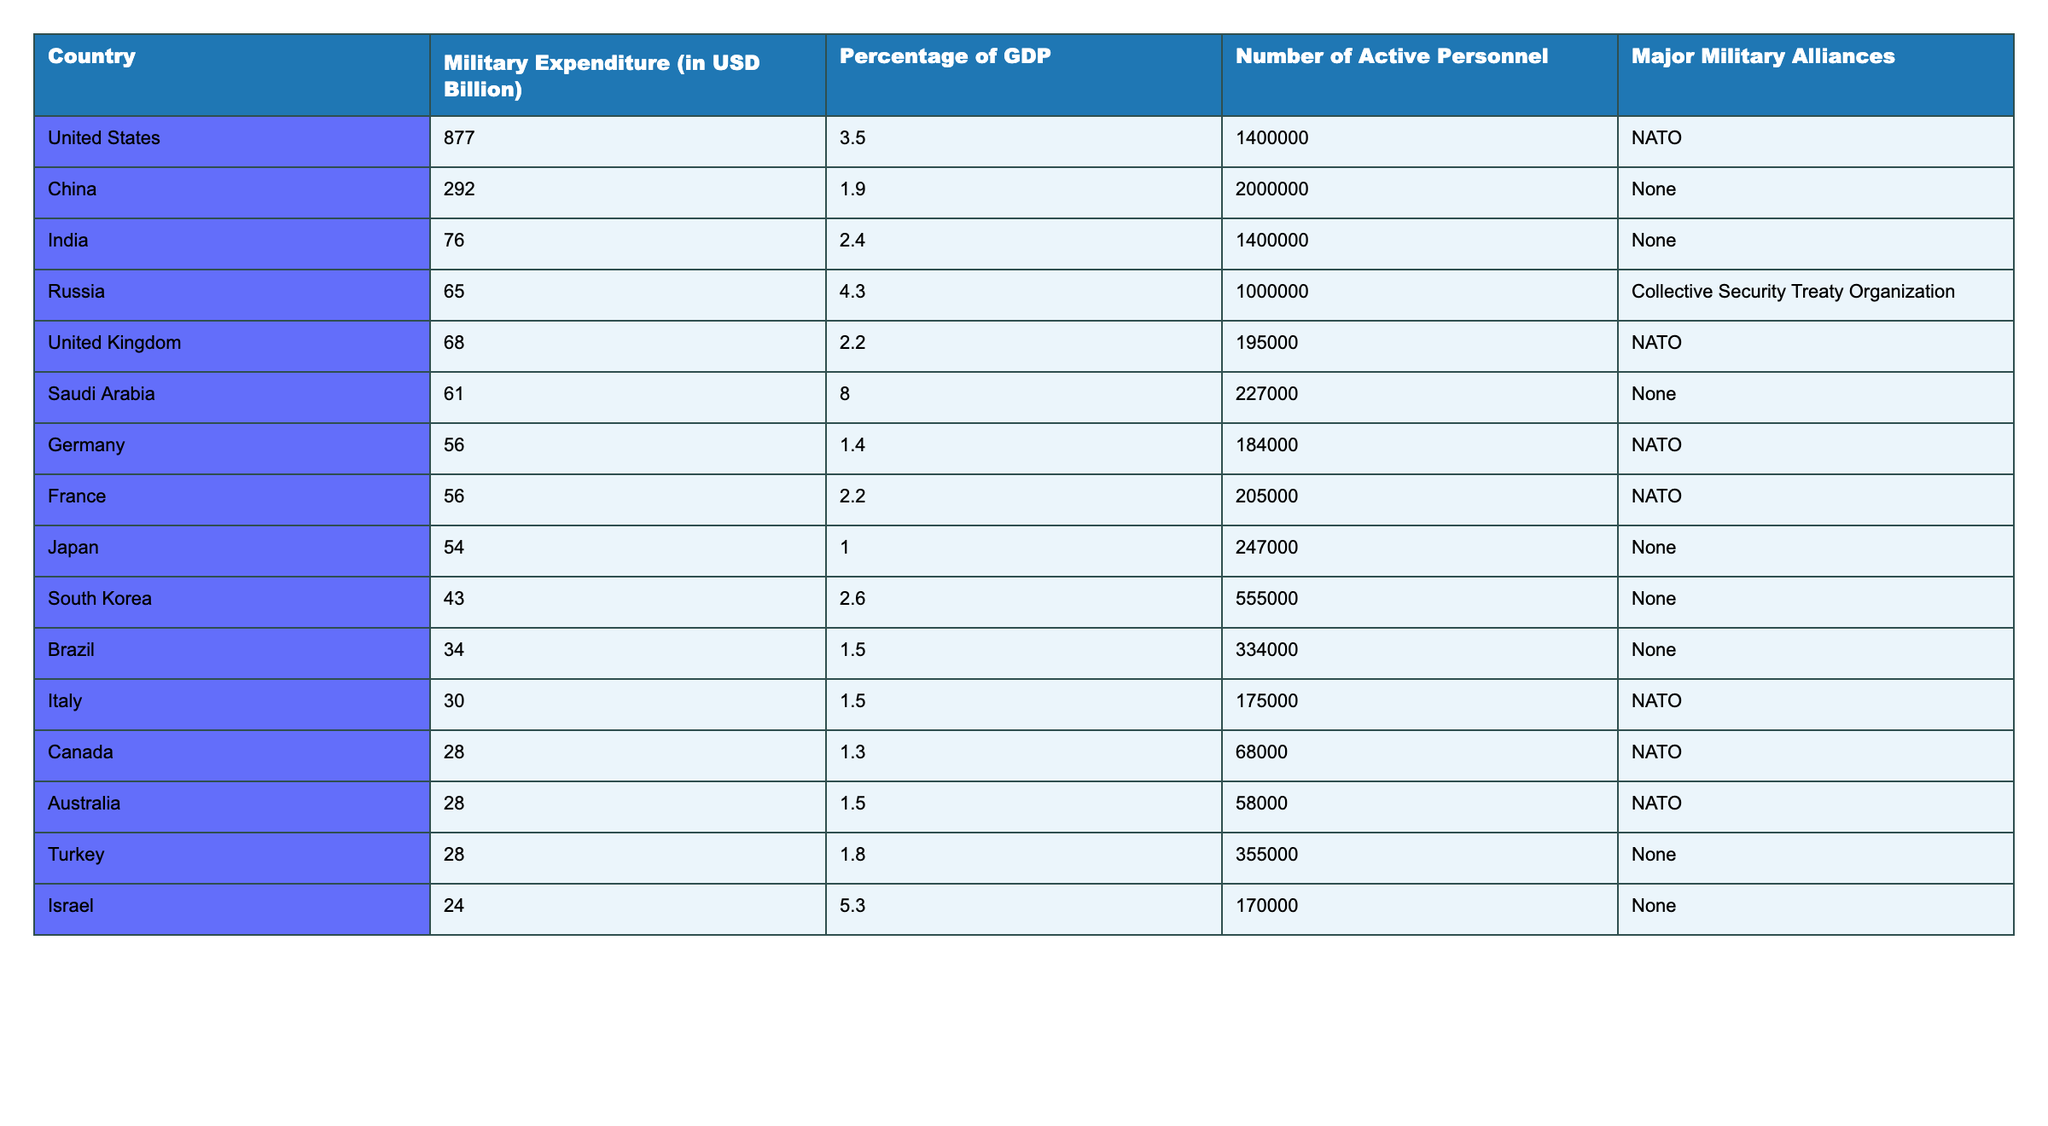What is the military expenditure of the United States in 2022? The table shows that the military expenditure of the United States is listed as 877.0 billion USD.
Answer: 877.0 billion USD How much is India's military expenditure compared to that of Russia? India's military expenditure is 76.0 billion USD, while Russia's is 65.0 billion USD. To find how much greater India's expenditure is, subtract: 76.0 - 65.0 = 11.0 billion USD.
Answer: 11.0 billion USD What percentage of GDP does Saudi Arabia allocate for military expenditure? The table indicates that Saudi Arabia allocates 8.0% of its GDP for military expenditure.
Answer: 8.0% Which country has the highest number of active personnel? China has the highest number of active personnel with 2,000,000, as listed in the table.
Answer: China Is the military expenditure of France greater than that of Germany? The table shows France's military expenditure is 56.0 billion USD, and Germany's is also 56.0 billion USD; therefore, France's expenditure is not greater than Germany's.
Answer: No What is the total military expenditure of all NATO countries listed? The expenditures for NATO countries (United States, United Kingdom, Germany, France, Italy, Canada, Australia) are 877.0 + 68.0 + 56.0 + 56.0 + 30.0 + 28.0 + 28.0 = 1,123.0 billion USD.
Answer: 1,123.0 billion USD What is the median military expenditure of the countries listed in the table? To find the median, first list all expenditures: 877.0, 292.0, 76.0, 65.0, 68.0, 61.0, 56.0, 56.0, 54.0, 43.0, 34.0, 30.0, 28.0, 28.0, 28.0, 24.0. There are 16 data points, so the median is the average of the 8th and 9th values in sorted order (56.0 and 54.0): (56.0 + 54.0) / 2 = 55.0 billion USD.
Answer: 55.0 billion USD Which country spends less on military than the percentage of GDP allocated by Saudi Arabia? Saudi Arabia allocates 8.0% of its GDP for military spending. Looking at the table, only Japan (1.0%) and Germany (1.4%) have lower percentages of GDP; therefore, they both spend less.
Answer: Japan and Germany How much more does the United States spend on military compared to the combined expenditure of Brazil and Turkey? Brazil's expenditure is 34.0 billion USD, and Turkey's is 28.0 billion USD. Their combined expenditure is 34.0 + 28.0 = 62.0 billion USD. The United States spends 877.0 billion USD, so the difference is 877.0 - 62.0 = 815.0 billion USD.
Answer: 815.0 billion USD 